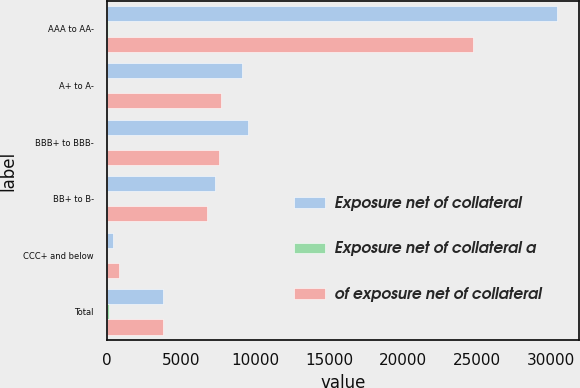<chart> <loc_0><loc_0><loc_500><loc_500><stacked_bar_chart><ecel><fcel>AAA to AA-<fcel>A+ to A-<fcel>BBB+ to BBB-<fcel>BB+ to B-<fcel>CCC+ and below<fcel>Total<nl><fcel>Exposure net of collateral<fcel>30384<fcel>9109<fcel>9522<fcel>7271<fcel>395<fcel>3799.5<nl><fcel>Exposure net of collateral a<fcel>53<fcel>16<fcel>17<fcel>13<fcel>1<fcel>100<nl><fcel>of exposure net of collateral<fcel>24697<fcel>7677<fcel>7564<fcel>6777<fcel>822<fcel>3799.5<nl></chart> 